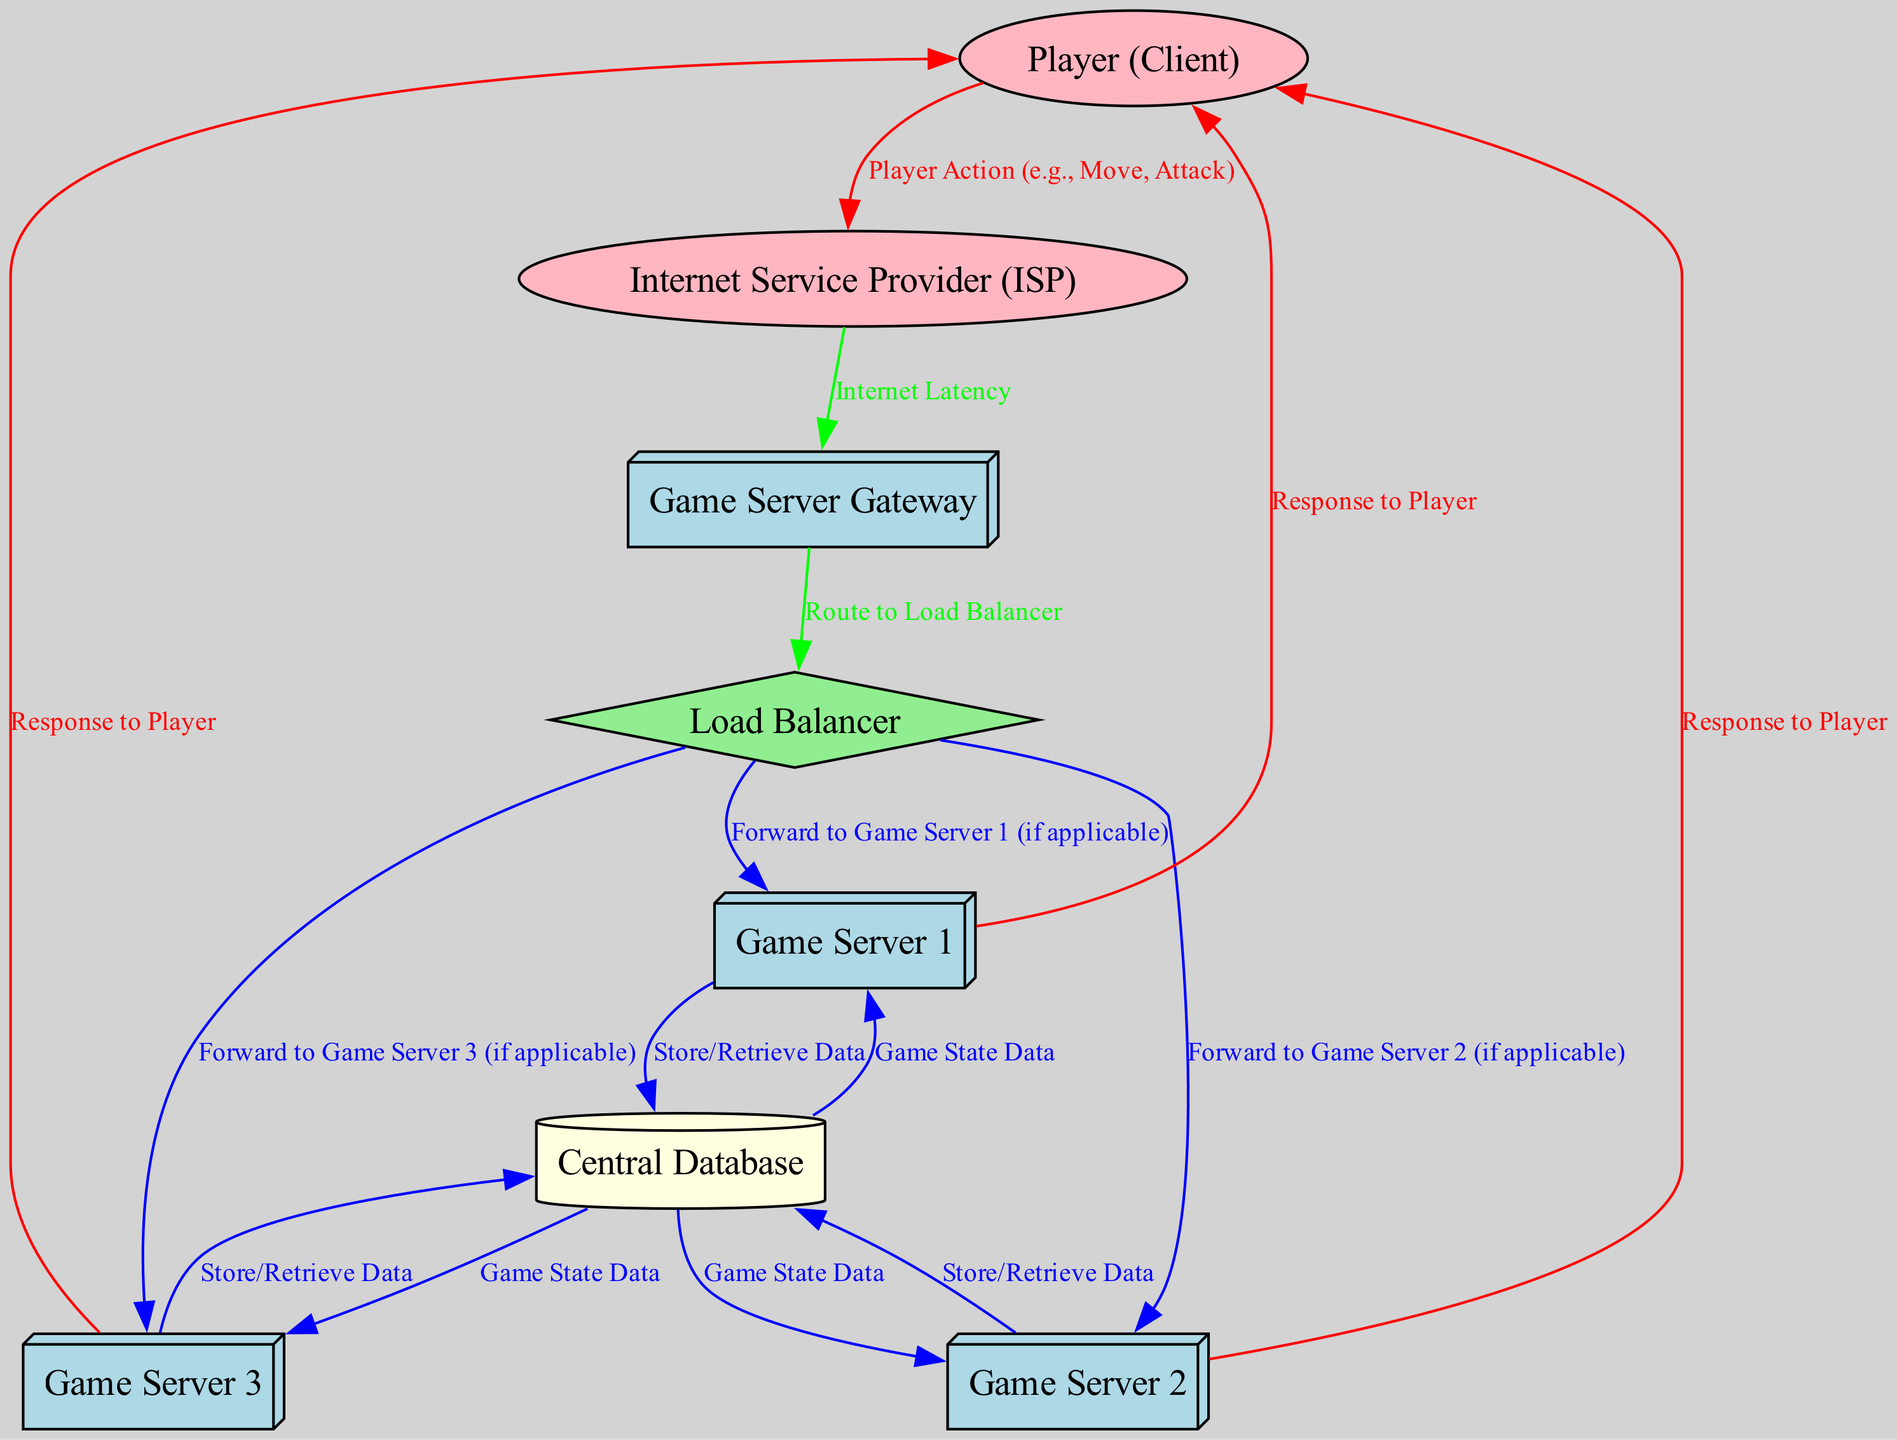What are the labels of the nodes in the diagram? The diagram includes the following nodes: Player (Client), Internet Service Provider (ISP), Game Server Gateway, Load Balancer, Game Server 1, Game Server 2, Game Server 3, and Central Database.
Answer: Player (Client), Internet Service Provider (ISP), Game Server Gateway, Load Balancer, Game Server 1, Game Server 2, Game Server 3, Central Database How many game servers are represented in the diagram? The diagram includes three distinct game servers labeled Game Server 1, Game Server 2, and Game Server 3, which can be counted from the nodes.
Answer: 3 What type of connection does the Load Balancer have with the Game Servers? The Load Balancer directs player actions to the game servers by forwarding requests to either Game Server 1, Game Server 2, or Game Server 3 as indicated in the diagram's edges.
Answer: Forward to Game Server 1, Game Server 2, Game Server 3 What is the first step when a player initiates an action? The player's action, such as moving or attacking, is first processed through the Player (Client) node before it travels to the Internet Service Provider (ISP).
Answer: Player Action (e.g., Move, Attack) Which component is responsible for managing the distribution of player actions? The Load Balancer is responsible for managing the distribution of player actions by routing these actions to the appropriate game server based on its load, facilitating efficient gameplay.
Answer: Load Balancer How do the Game Servers retrieve game state data from the Central Database? Each game server connects to the Central Database to retrieve or store the game state data through directed connections indicated in the diagram. Each server has a specific link marked ‘Game State Data’ leading to the database.
Answer: Store/Retrieve Data Which color represents the edges between the Game Servers and the client? The edges between the Game Servers and the client are colored red, indicating that they represent responses sent back to the player after processing their actions.
Answer: Red What is the role of the ISP in the process illustrated by the diagram? The Internet Service Provider (ISP) acts as an intermediary that conveys the player's actions from the client to the game server gateway, introducing internet latency along the route.
Answer: Intermediary for Player Actions Which node stores and retrieves data for all game servers? The Central Database is the node responsible for storing and retrieving data for all game servers, facilitating synchronized gameplay by ensuring each server can access the necessary game state information.
Answer: Central Database 